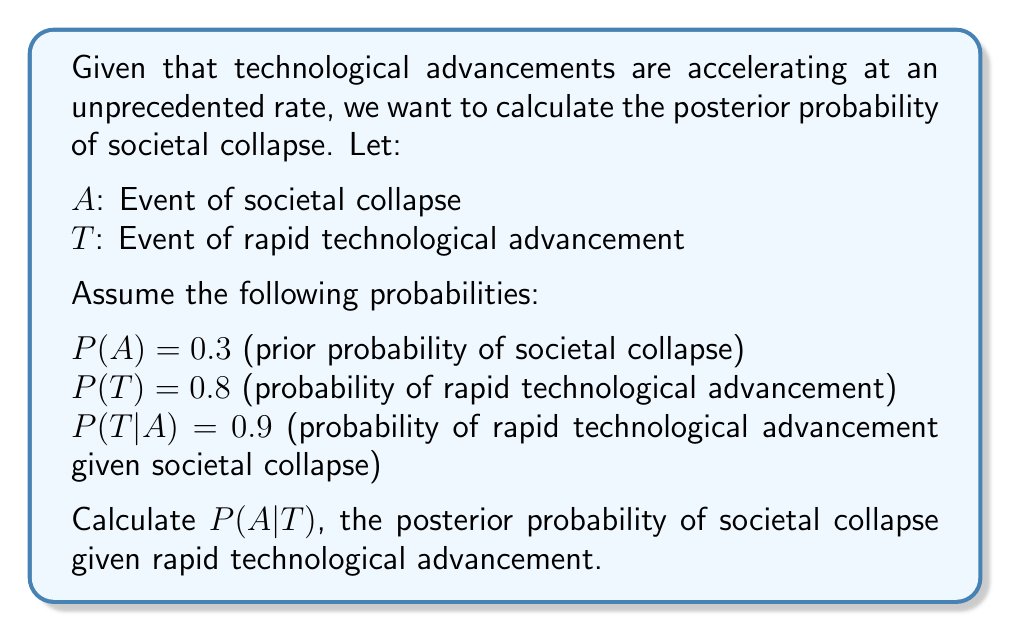What is the answer to this math problem? To solve this problem, we'll use Bayes' Theorem:

$$P(A|T) = \frac{P(T|A) \cdot P(A)}{P(T)}$$

We're given:
$P(A) = 0.3$
$P(T) = 0.8$
$P(T|A) = 0.9$

Step 1: Calculate $P(T|A) \cdot P(A)$
$$P(T|A) \cdot P(A) = 0.9 \cdot 0.3 = 0.27$$

Step 2: Use the law of total probability to calculate $P(T)$
$$P(T) = P(T|A) \cdot P(A) + P(T|\neg A) \cdot P(\neg A)$$

We need to find $P(T|\neg A)$:
$$P(T|\neg A) = \frac{P(T) - P(T|A) \cdot P(A)}{P(\neg A)} = \frac{0.8 - 0.9 \cdot 0.3}{0.7} \approx 0.7429$$

Step 3: Apply Bayes' Theorem
$$P(A|T) = \frac{0.27}{0.8} = 0.3375$$

Therefore, the posterior probability of societal collapse given rapid technological advancement is approximately 0.3375 or 33.75%.
Answer: $P(A|T) \approx 0.3375$ or $33.75\%$ 